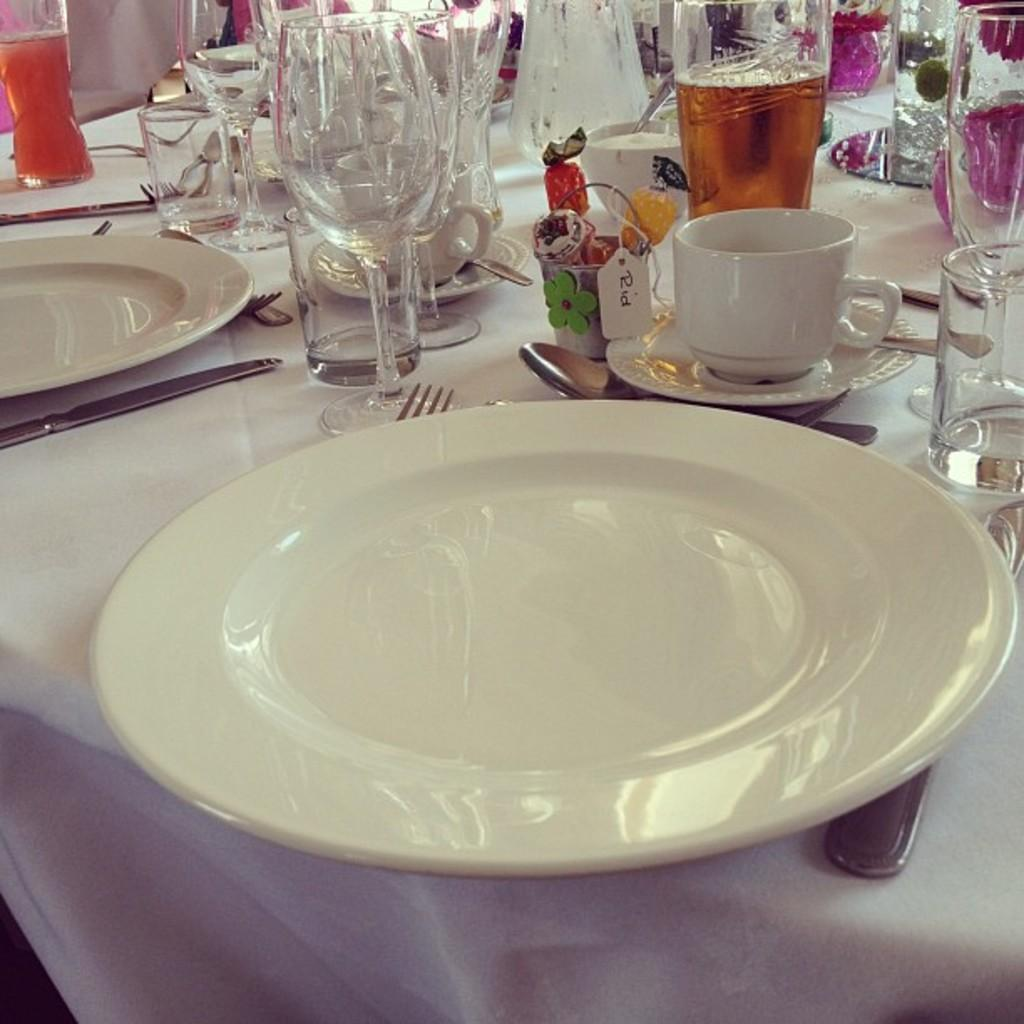Where was the image taken? The image was taken at a dining table. What is covering the dining table? There is a white cloth on the dining table. What types of tableware are present on the dining table? Glasses, plates, and cups are visible on the dining table. What utensils are beside the plate? Forks and spoons are beside the plate. Can you see a snake slithering across the dining table in the image? No, there is no snake present in the image. Is there any indication of a war happening in the image? No, there is no indication of a war in the image; it is a peaceful dining table setting. 